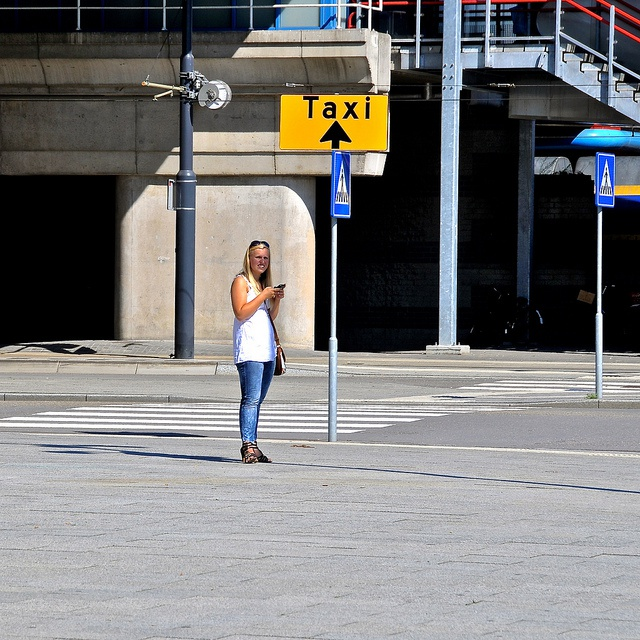Describe the objects in this image and their specific colors. I can see people in black, white, brown, and navy tones, handbag in black, maroon, lightgray, and darkgray tones, and cell phone in black, gray, and maroon tones in this image. 